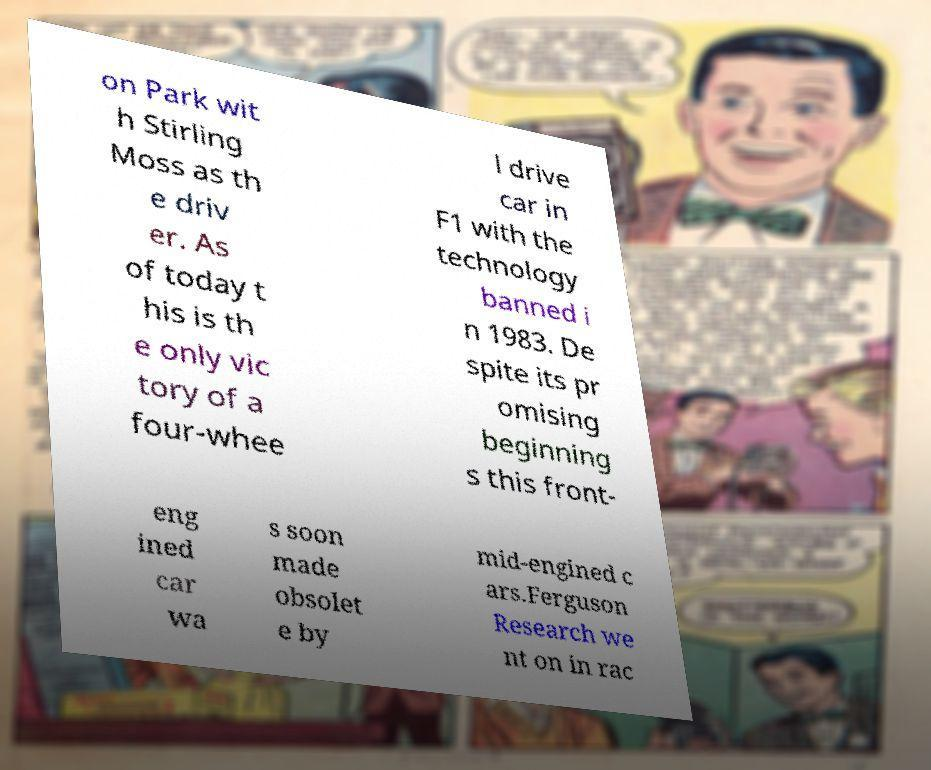What messages or text are displayed in this image? I need them in a readable, typed format. on Park wit h Stirling Moss as th e driv er. As of today t his is th e only vic tory of a four-whee l drive car in F1 with the technology banned i n 1983. De spite its pr omising beginning s this front- eng ined car wa s soon made obsolet e by mid-engined c ars.Ferguson Research we nt on in rac 